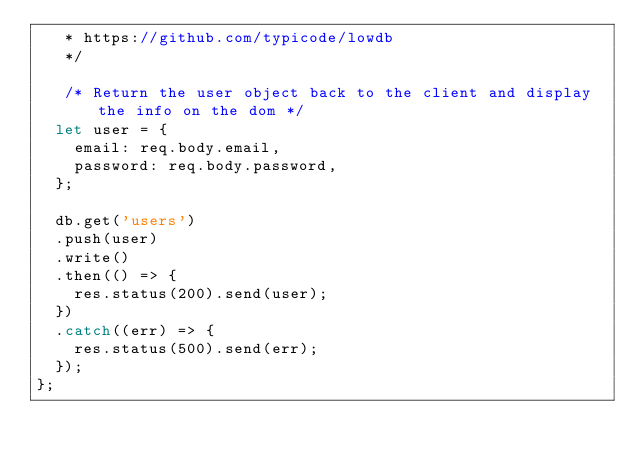<code> <loc_0><loc_0><loc_500><loc_500><_JavaScript_>   * https://github.com/typicode/lowdb
   */

   /* Return the user object back to the client and display the info on the dom */
  let user = {
    email: req.body.email,
    password: req.body.password,
  };

  db.get('users')
  .push(user)
  .write()
  .then(() => {
    res.status(200).send(user);
  })
  .catch((err) => {
    res.status(500).send(err);
  });
};
</code> 